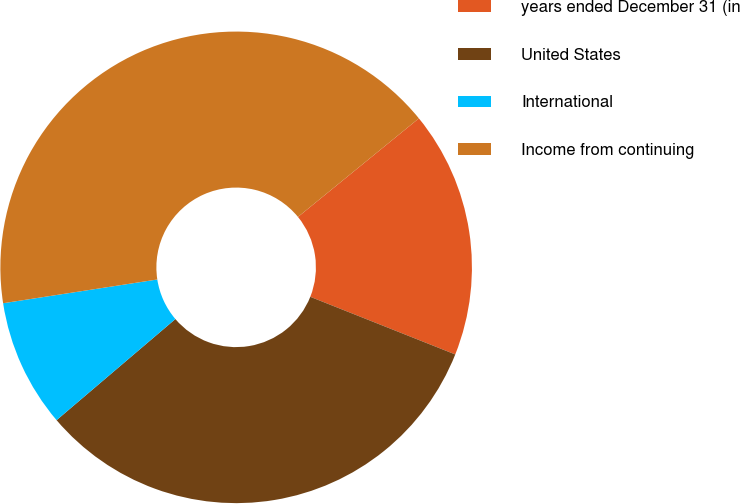Convert chart. <chart><loc_0><loc_0><loc_500><loc_500><pie_chart><fcel>years ended December 31 (in<fcel>United States<fcel>International<fcel>Income from continuing<nl><fcel>16.91%<fcel>32.76%<fcel>8.79%<fcel>41.55%<nl></chart> 